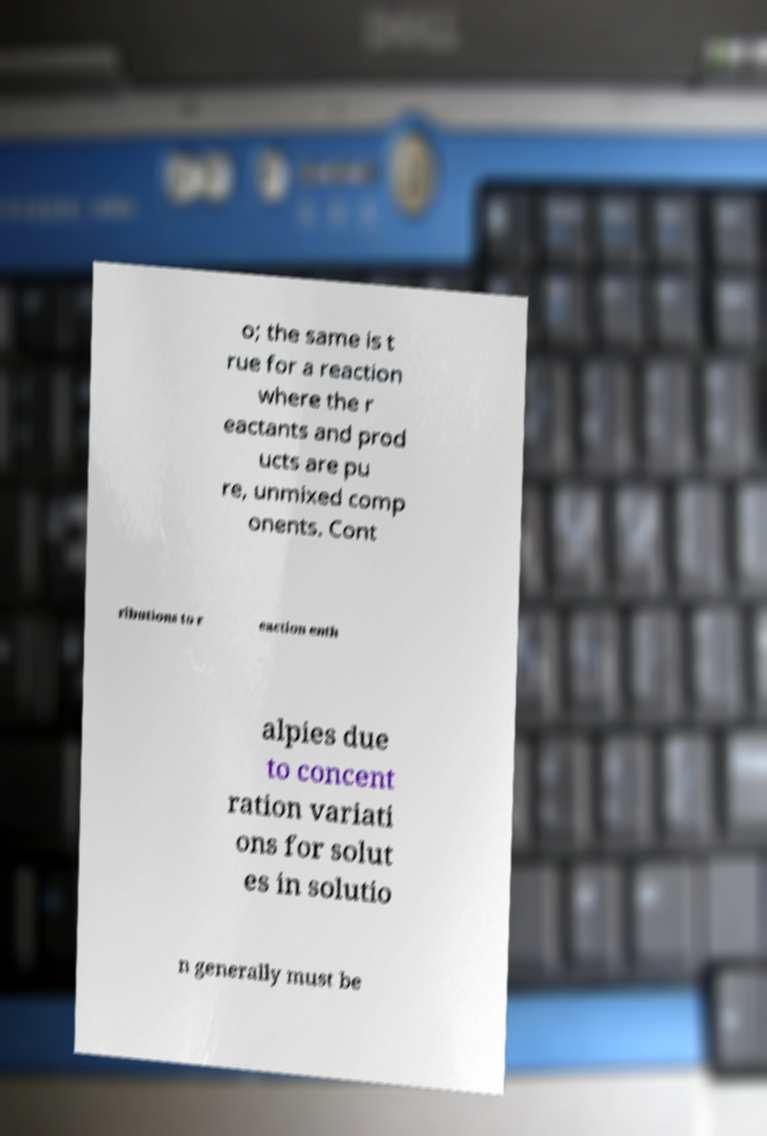Could you assist in decoding the text presented in this image and type it out clearly? o; the same is t rue for a reaction where the r eactants and prod ucts are pu re, unmixed comp onents. Cont ributions to r eaction enth alpies due to concent ration variati ons for solut es in solutio n generally must be 